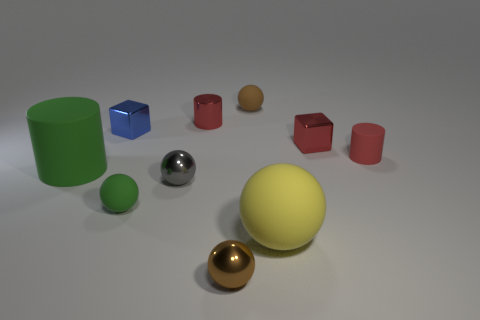Is there any other thing that has the same material as the gray thing?
Keep it short and to the point. Yes. The yellow sphere has what size?
Ensure brevity in your answer.  Large. What is the color of the small ball that is both behind the green matte sphere and on the right side of the red metallic cylinder?
Your answer should be very brief. Brown. Is the number of big matte cylinders greater than the number of shiny cubes?
Offer a very short reply. No. What number of objects are large yellow balls or red metal objects that are left of the brown metallic object?
Make the answer very short. 2. Do the yellow matte object and the brown matte object have the same size?
Your response must be concise. No. Are there any large green cylinders behind the big green rubber object?
Ensure brevity in your answer.  No. What is the size of the rubber ball that is in front of the small rubber cylinder and left of the yellow ball?
Offer a terse response. Small. How many things are red cylinders or big green cylinders?
Offer a terse response. 3. Does the gray metal object have the same size as the green thing that is behind the green ball?
Your response must be concise. No. 